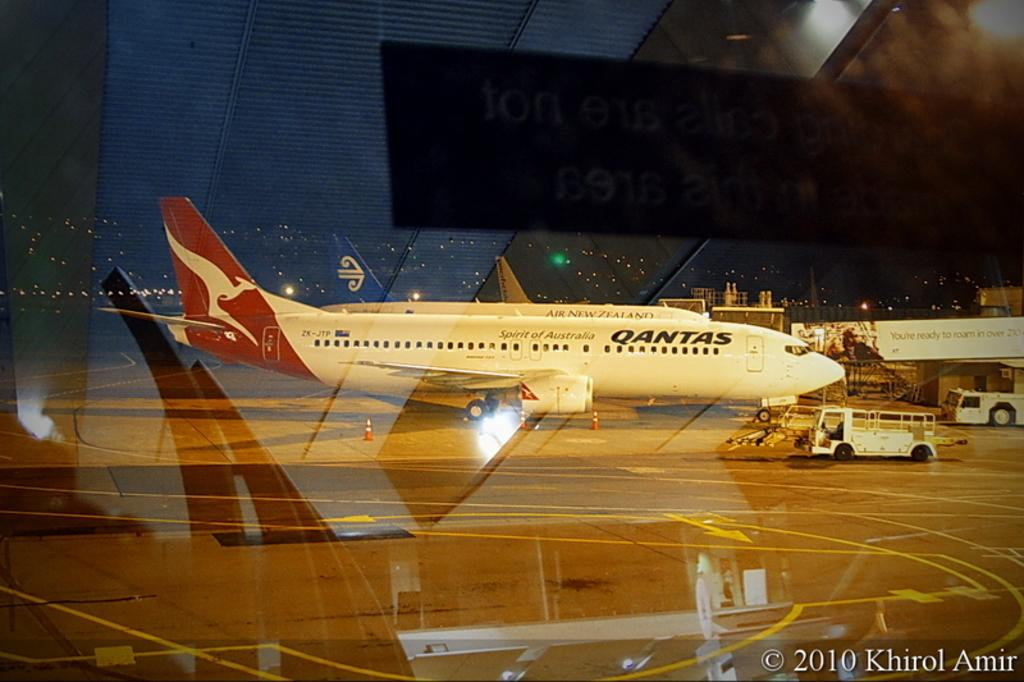<image>
Create a compact narrative representing the image presented. A worker drives a truck towards a Quantas airplane stopped by an airport terminal. 